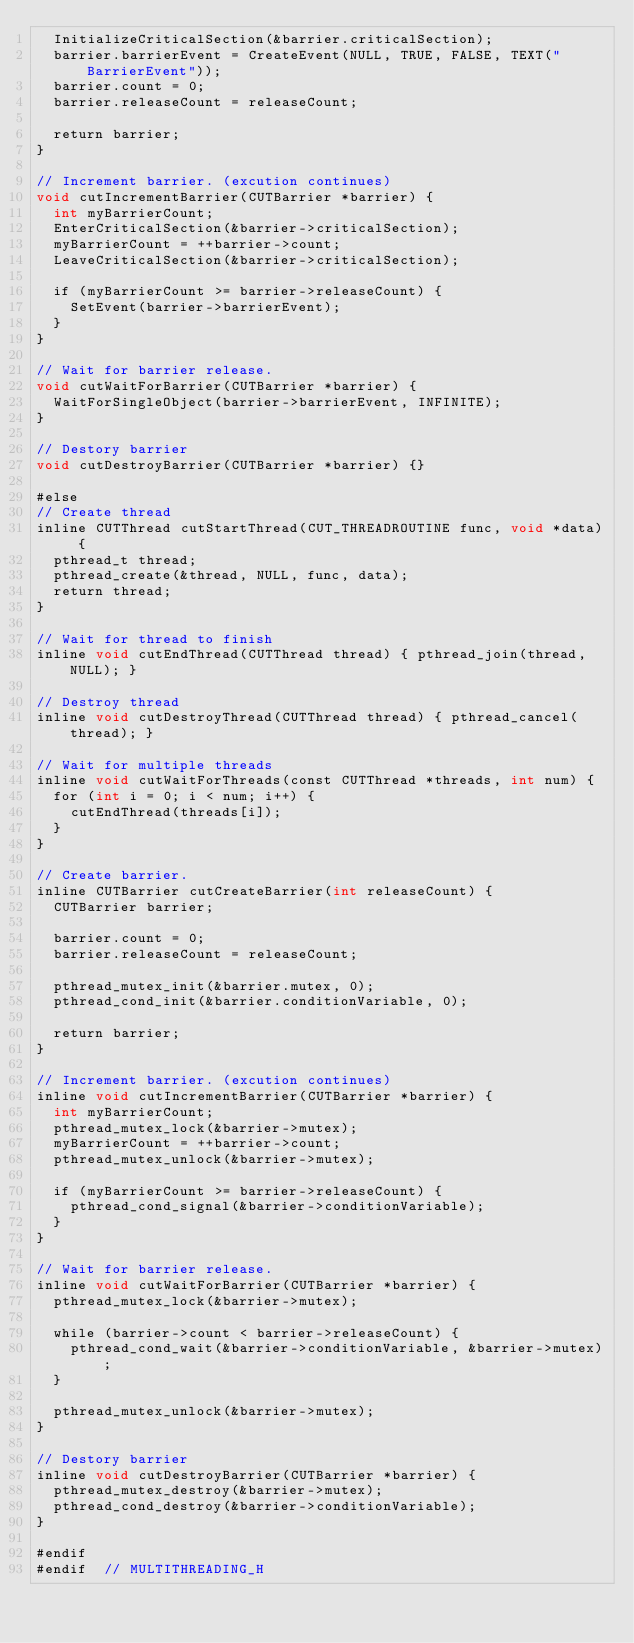Convert code to text. <code><loc_0><loc_0><loc_500><loc_500><_Cuda_>  InitializeCriticalSection(&barrier.criticalSection);
  barrier.barrierEvent = CreateEvent(NULL, TRUE, FALSE, TEXT("BarrierEvent"));
  barrier.count = 0;
  barrier.releaseCount = releaseCount;

  return barrier;
}

// Increment barrier. (excution continues)
void cutIncrementBarrier(CUTBarrier *barrier) {
  int myBarrierCount;
  EnterCriticalSection(&barrier->criticalSection);
  myBarrierCount = ++barrier->count;
  LeaveCriticalSection(&barrier->criticalSection);

  if (myBarrierCount >= barrier->releaseCount) {
    SetEvent(barrier->barrierEvent);
  }
}

// Wait for barrier release.
void cutWaitForBarrier(CUTBarrier *barrier) {
  WaitForSingleObject(barrier->barrierEvent, INFINITE);
}

// Destory barrier
void cutDestroyBarrier(CUTBarrier *barrier) {}

#else
// Create thread
inline CUTThread cutStartThread(CUT_THREADROUTINE func, void *data) {
  pthread_t thread;
  pthread_create(&thread, NULL, func, data);
  return thread;
}

// Wait for thread to finish
inline void cutEndThread(CUTThread thread) { pthread_join(thread, NULL); }

// Destroy thread
inline void cutDestroyThread(CUTThread thread) { pthread_cancel(thread); }

// Wait for multiple threads
inline void cutWaitForThreads(const CUTThread *threads, int num) {
  for (int i = 0; i < num; i++) {
    cutEndThread(threads[i]);
  }
}

// Create barrier.
inline CUTBarrier cutCreateBarrier(int releaseCount) {
  CUTBarrier barrier;

  barrier.count = 0;
  barrier.releaseCount = releaseCount;

  pthread_mutex_init(&barrier.mutex, 0);
  pthread_cond_init(&barrier.conditionVariable, 0);

  return barrier;
}

// Increment barrier. (excution continues)
inline void cutIncrementBarrier(CUTBarrier *barrier) {
  int myBarrierCount;
  pthread_mutex_lock(&barrier->mutex);
  myBarrierCount = ++barrier->count;
  pthread_mutex_unlock(&barrier->mutex);

  if (myBarrierCount >= barrier->releaseCount) {
    pthread_cond_signal(&barrier->conditionVariable);
  }
}

// Wait for barrier release.
inline void cutWaitForBarrier(CUTBarrier *barrier) {
  pthread_mutex_lock(&barrier->mutex);

  while (barrier->count < barrier->releaseCount) {
    pthread_cond_wait(&barrier->conditionVariable, &barrier->mutex);
  }

  pthread_mutex_unlock(&barrier->mutex);
}

// Destory barrier
inline void cutDestroyBarrier(CUTBarrier *barrier) {
  pthread_mutex_destroy(&barrier->mutex);
  pthread_cond_destroy(&barrier->conditionVariable);
}

#endif
#endif  // MULTITHREADING_H
</code> 